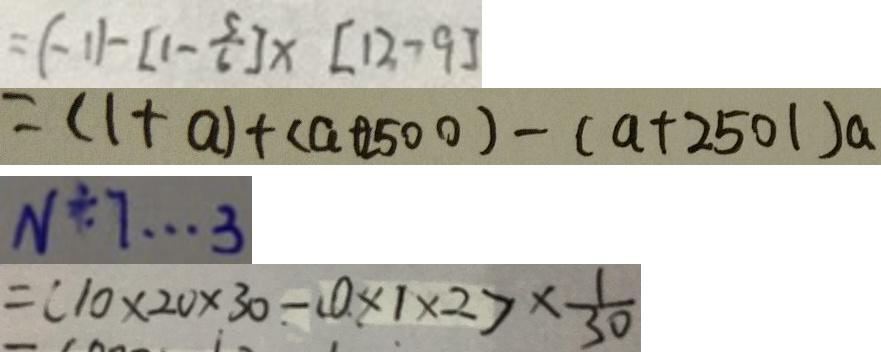<formula> <loc_0><loc_0><loc_500><loc_500>= ( - 1 ) - [ 1 - \frac { 5 } { 6 } ] \times [ 1 2 - 9 ] 
 = ( 1 + a ) \times ( a + 2 5 0 0 ) - ( a + 2 5 0 1 ) \times a 
 N \div 7 \cdots 3 
 = ( 1 0 \times 2 0 \times 3 0 - 0 \times 1 \times 2 ) \times \frac { 1 } { 3 0 }</formula> 